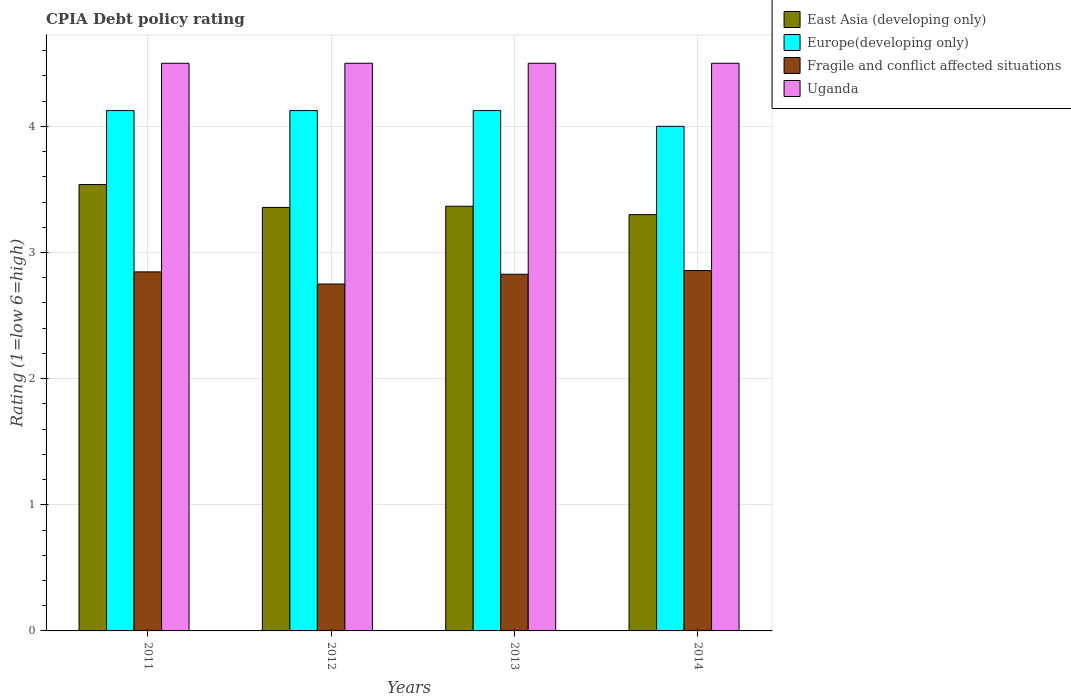How many different coloured bars are there?
Keep it short and to the point. 4. How many groups of bars are there?
Give a very brief answer. 4. Are the number of bars per tick equal to the number of legend labels?
Your response must be concise. Yes. How many bars are there on the 2nd tick from the left?
Offer a very short reply. 4. How many bars are there on the 1st tick from the right?
Keep it short and to the point. 4. What is the label of the 2nd group of bars from the left?
Offer a terse response. 2012. What is the CPIA rating in Europe(developing only) in 2014?
Ensure brevity in your answer.  4. Across all years, what is the maximum CPIA rating in Uganda?
Provide a short and direct response. 4.5. Across all years, what is the minimum CPIA rating in Europe(developing only)?
Give a very brief answer. 4. What is the total CPIA rating in East Asia (developing only) in the graph?
Provide a succinct answer. 13.56. What is the difference between the CPIA rating in East Asia (developing only) in 2011 and that in 2013?
Give a very brief answer. 0.17. What is the difference between the CPIA rating in East Asia (developing only) in 2011 and the CPIA rating in Europe(developing only) in 2013?
Offer a terse response. -0.59. What is the average CPIA rating in Europe(developing only) per year?
Provide a succinct answer. 4.09. In the year 2011, what is the difference between the CPIA rating in Fragile and conflict affected situations and CPIA rating in Europe(developing only)?
Ensure brevity in your answer.  -1.28. Is the difference between the CPIA rating in Fragile and conflict affected situations in 2012 and 2013 greater than the difference between the CPIA rating in Europe(developing only) in 2012 and 2013?
Provide a short and direct response. No. What is the difference between the highest and the second highest CPIA rating in East Asia (developing only)?
Give a very brief answer. 0.17. What is the difference between the highest and the lowest CPIA rating in Fragile and conflict affected situations?
Your answer should be compact. 0.11. Is it the case that in every year, the sum of the CPIA rating in Europe(developing only) and CPIA rating in East Asia (developing only) is greater than the sum of CPIA rating in Fragile and conflict affected situations and CPIA rating in Uganda?
Provide a succinct answer. No. What does the 1st bar from the left in 2012 represents?
Provide a succinct answer. East Asia (developing only). What does the 4th bar from the right in 2014 represents?
Your answer should be very brief. East Asia (developing only). Is it the case that in every year, the sum of the CPIA rating in East Asia (developing only) and CPIA rating in Uganda is greater than the CPIA rating in Europe(developing only)?
Keep it short and to the point. Yes. How many years are there in the graph?
Your answer should be very brief. 4. What is the difference between two consecutive major ticks on the Y-axis?
Ensure brevity in your answer.  1. Does the graph contain any zero values?
Give a very brief answer. No. Where does the legend appear in the graph?
Your answer should be very brief. Top right. What is the title of the graph?
Provide a short and direct response. CPIA Debt policy rating. Does "Ecuador" appear as one of the legend labels in the graph?
Provide a succinct answer. No. What is the label or title of the Y-axis?
Make the answer very short. Rating (1=low 6=high). What is the Rating (1=low 6=high) of East Asia (developing only) in 2011?
Offer a terse response. 3.54. What is the Rating (1=low 6=high) in Europe(developing only) in 2011?
Make the answer very short. 4.12. What is the Rating (1=low 6=high) in Fragile and conflict affected situations in 2011?
Make the answer very short. 2.85. What is the Rating (1=low 6=high) in East Asia (developing only) in 2012?
Your answer should be very brief. 3.36. What is the Rating (1=low 6=high) in Europe(developing only) in 2012?
Your response must be concise. 4.12. What is the Rating (1=low 6=high) of Fragile and conflict affected situations in 2012?
Make the answer very short. 2.75. What is the Rating (1=low 6=high) in Uganda in 2012?
Offer a terse response. 4.5. What is the Rating (1=low 6=high) in East Asia (developing only) in 2013?
Your response must be concise. 3.37. What is the Rating (1=low 6=high) of Europe(developing only) in 2013?
Make the answer very short. 4.12. What is the Rating (1=low 6=high) of Fragile and conflict affected situations in 2013?
Your answer should be compact. 2.83. What is the Rating (1=low 6=high) in Uganda in 2013?
Ensure brevity in your answer.  4.5. What is the Rating (1=low 6=high) of East Asia (developing only) in 2014?
Make the answer very short. 3.3. What is the Rating (1=low 6=high) of Europe(developing only) in 2014?
Offer a terse response. 4. What is the Rating (1=low 6=high) in Fragile and conflict affected situations in 2014?
Keep it short and to the point. 2.86. What is the Rating (1=low 6=high) in Uganda in 2014?
Your answer should be very brief. 4.5. Across all years, what is the maximum Rating (1=low 6=high) of East Asia (developing only)?
Your answer should be very brief. 3.54. Across all years, what is the maximum Rating (1=low 6=high) in Europe(developing only)?
Your response must be concise. 4.12. Across all years, what is the maximum Rating (1=low 6=high) of Fragile and conflict affected situations?
Offer a terse response. 2.86. Across all years, what is the maximum Rating (1=low 6=high) of Uganda?
Offer a very short reply. 4.5. Across all years, what is the minimum Rating (1=low 6=high) of East Asia (developing only)?
Offer a very short reply. 3.3. Across all years, what is the minimum Rating (1=low 6=high) of Europe(developing only)?
Keep it short and to the point. 4. Across all years, what is the minimum Rating (1=low 6=high) in Fragile and conflict affected situations?
Make the answer very short. 2.75. Across all years, what is the minimum Rating (1=low 6=high) of Uganda?
Provide a short and direct response. 4.5. What is the total Rating (1=low 6=high) of East Asia (developing only) in the graph?
Make the answer very short. 13.56. What is the total Rating (1=low 6=high) in Europe(developing only) in the graph?
Provide a short and direct response. 16.38. What is the total Rating (1=low 6=high) in Fragile and conflict affected situations in the graph?
Your answer should be very brief. 11.28. What is the difference between the Rating (1=low 6=high) of East Asia (developing only) in 2011 and that in 2012?
Provide a succinct answer. 0.18. What is the difference between the Rating (1=low 6=high) in Fragile and conflict affected situations in 2011 and that in 2012?
Offer a very short reply. 0.1. What is the difference between the Rating (1=low 6=high) of East Asia (developing only) in 2011 and that in 2013?
Make the answer very short. 0.17. What is the difference between the Rating (1=low 6=high) of Europe(developing only) in 2011 and that in 2013?
Ensure brevity in your answer.  0. What is the difference between the Rating (1=low 6=high) of Fragile and conflict affected situations in 2011 and that in 2013?
Provide a succinct answer. 0.02. What is the difference between the Rating (1=low 6=high) in Uganda in 2011 and that in 2013?
Ensure brevity in your answer.  0. What is the difference between the Rating (1=low 6=high) of East Asia (developing only) in 2011 and that in 2014?
Give a very brief answer. 0.24. What is the difference between the Rating (1=low 6=high) in Fragile and conflict affected situations in 2011 and that in 2014?
Offer a terse response. -0.01. What is the difference between the Rating (1=low 6=high) of Uganda in 2011 and that in 2014?
Your response must be concise. 0. What is the difference between the Rating (1=low 6=high) in East Asia (developing only) in 2012 and that in 2013?
Give a very brief answer. -0.01. What is the difference between the Rating (1=low 6=high) in Fragile and conflict affected situations in 2012 and that in 2013?
Offer a very short reply. -0.08. What is the difference between the Rating (1=low 6=high) in Uganda in 2012 and that in 2013?
Your answer should be compact. 0. What is the difference between the Rating (1=low 6=high) of East Asia (developing only) in 2012 and that in 2014?
Your response must be concise. 0.06. What is the difference between the Rating (1=low 6=high) of Fragile and conflict affected situations in 2012 and that in 2014?
Offer a very short reply. -0.11. What is the difference between the Rating (1=low 6=high) in Uganda in 2012 and that in 2014?
Provide a succinct answer. 0. What is the difference between the Rating (1=low 6=high) in East Asia (developing only) in 2013 and that in 2014?
Your response must be concise. 0.07. What is the difference between the Rating (1=low 6=high) in Fragile and conflict affected situations in 2013 and that in 2014?
Your answer should be compact. -0.03. What is the difference between the Rating (1=low 6=high) of East Asia (developing only) in 2011 and the Rating (1=low 6=high) of Europe(developing only) in 2012?
Make the answer very short. -0.59. What is the difference between the Rating (1=low 6=high) of East Asia (developing only) in 2011 and the Rating (1=low 6=high) of Fragile and conflict affected situations in 2012?
Make the answer very short. 0.79. What is the difference between the Rating (1=low 6=high) in East Asia (developing only) in 2011 and the Rating (1=low 6=high) in Uganda in 2012?
Keep it short and to the point. -0.96. What is the difference between the Rating (1=low 6=high) of Europe(developing only) in 2011 and the Rating (1=low 6=high) of Fragile and conflict affected situations in 2012?
Give a very brief answer. 1.38. What is the difference between the Rating (1=low 6=high) of Europe(developing only) in 2011 and the Rating (1=low 6=high) of Uganda in 2012?
Offer a very short reply. -0.38. What is the difference between the Rating (1=low 6=high) of Fragile and conflict affected situations in 2011 and the Rating (1=low 6=high) of Uganda in 2012?
Keep it short and to the point. -1.65. What is the difference between the Rating (1=low 6=high) of East Asia (developing only) in 2011 and the Rating (1=low 6=high) of Europe(developing only) in 2013?
Ensure brevity in your answer.  -0.59. What is the difference between the Rating (1=low 6=high) in East Asia (developing only) in 2011 and the Rating (1=low 6=high) in Fragile and conflict affected situations in 2013?
Ensure brevity in your answer.  0.71. What is the difference between the Rating (1=low 6=high) of East Asia (developing only) in 2011 and the Rating (1=low 6=high) of Uganda in 2013?
Ensure brevity in your answer.  -0.96. What is the difference between the Rating (1=low 6=high) in Europe(developing only) in 2011 and the Rating (1=low 6=high) in Fragile and conflict affected situations in 2013?
Make the answer very short. 1.3. What is the difference between the Rating (1=low 6=high) of Europe(developing only) in 2011 and the Rating (1=low 6=high) of Uganda in 2013?
Provide a succinct answer. -0.38. What is the difference between the Rating (1=low 6=high) of Fragile and conflict affected situations in 2011 and the Rating (1=low 6=high) of Uganda in 2013?
Your answer should be very brief. -1.65. What is the difference between the Rating (1=low 6=high) of East Asia (developing only) in 2011 and the Rating (1=low 6=high) of Europe(developing only) in 2014?
Ensure brevity in your answer.  -0.46. What is the difference between the Rating (1=low 6=high) in East Asia (developing only) in 2011 and the Rating (1=low 6=high) in Fragile and conflict affected situations in 2014?
Provide a short and direct response. 0.68. What is the difference between the Rating (1=low 6=high) of East Asia (developing only) in 2011 and the Rating (1=low 6=high) of Uganda in 2014?
Provide a succinct answer. -0.96. What is the difference between the Rating (1=low 6=high) in Europe(developing only) in 2011 and the Rating (1=low 6=high) in Fragile and conflict affected situations in 2014?
Keep it short and to the point. 1.27. What is the difference between the Rating (1=low 6=high) of Europe(developing only) in 2011 and the Rating (1=low 6=high) of Uganda in 2014?
Keep it short and to the point. -0.38. What is the difference between the Rating (1=low 6=high) in Fragile and conflict affected situations in 2011 and the Rating (1=low 6=high) in Uganda in 2014?
Make the answer very short. -1.65. What is the difference between the Rating (1=low 6=high) of East Asia (developing only) in 2012 and the Rating (1=low 6=high) of Europe(developing only) in 2013?
Your answer should be very brief. -0.77. What is the difference between the Rating (1=low 6=high) in East Asia (developing only) in 2012 and the Rating (1=low 6=high) in Fragile and conflict affected situations in 2013?
Your response must be concise. 0.53. What is the difference between the Rating (1=low 6=high) of East Asia (developing only) in 2012 and the Rating (1=low 6=high) of Uganda in 2013?
Offer a terse response. -1.14. What is the difference between the Rating (1=low 6=high) in Europe(developing only) in 2012 and the Rating (1=low 6=high) in Fragile and conflict affected situations in 2013?
Offer a very short reply. 1.3. What is the difference between the Rating (1=low 6=high) of Europe(developing only) in 2012 and the Rating (1=low 6=high) of Uganda in 2013?
Ensure brevity in your answer.  -0.38. What is the difference between the Rating (1=low 6=high) of Fragile and conflict affected situations in 2012 and the Rating (1=low 6=high) of Uganda in 2013?
Offer a terse response. -1.75. What is the difference between the Rating (1=low 6=high) in East Asia (developing only) in 2012 and the Rating (1=low 6=high) in Europe(developing only) in 2014?
Ensure brevity in your answer.  -0.64. What is the difference between the Rating (1=low 6=high) of East Asia (developing only) in 2012 and the Rating (1=low 6=high) of Fragile and conflict affected situations in 2014?
Ensure brevity in your answer.  0.5. What is the difference between the Rating (1=low 6=high) of East Asia (developing only) in 2012 and the Rating (1=low 6=high) of Uganda in 2014?
Keep it short and to the point. -1.14. What is the difference between the Rating (1=low 6=high) of Europe(developing only) in 2012 and the Rating (1=low 6=high) of Fragile and conflict affected situations in 2014?
Your answer should be very brief. 1.27. What is the difference between the Rating (1=low 6=high) of Europe(developing only) in 2012 and the Rating (1=low 6=high) of Uganda in 2014?
Provide a succinct answer. -0.38. What is the difference between the Rating (1=low 6=high) of Fragile and conflict affected situations in 2012 and the Rating (1=low 6=high) of Uganda in 2014?
Your answer should be very brief. -1.75. What is the difference between the Rating (1=low 6=high) in East Asia (developing only) in 2013 and the Rating (1=low 6=high) in Europe(developing only) in 2014?
Offer a terse response. -0.63. What is the difference between the Rating (1=low 6=high) in East Asia (developing only) in 2013 and the Rating (1=low 6=high) in Fragile and conflict affected situations in 2014?
Offer a terse response. 0.51. What is the difference between the Rating (1=low 6=high) in East Asia (developing only) in 2013 and the Rating (1=low 6=high) in Uganda in 2014?
Ensure brevity in your answer.  -1.13. What is the difference between the Rating (1=low 6=high) of Europe(developing only) in 2013 and the Rating (1=low 6=high) of Fragile and conflict affected situations in 2014?
Your answer should be very brief. 1.27. What is the difference between the Rating (1=low 6=high) of Europe(developing only) in 2013 and the Rating (1=low 6=high) of Uganda in 2014?
Offer a very short reply. -0.38. What is the difference between the Rating (1=low 6=high) of Fragile and conflict affected situations in 2013 and the Rating (1=low 6=high) of Uganda in 2014?
Your answer should be very brief. -1.67. What is the average Rating (1=low 6=high) in East Asia (developing only) per year?
Provide a succinct answer. 3.39. What is the average Rating (1=low 6=high) in Europe(developing only) per year?
Provide a short and direct response. 4.09. What is the average Rating (1=low 6=high) in Fragile and conflict affected situations per year?
Offer a terse response. 2.82. What is the average Rating (1=low 6=high) of Uganda per year?
Keep it short and to the point. 4.5. In the year 2011, what is the difference between the Rating (1=low 6=high) of East Asia (developing only) and Rating (1=low 6=high) of Europe(developing only)?
Your answer should be very brief. -0.59. In the year 2011, what is the difference between the Rating (1=low 6=high) of East Asia (developing only) and Rating (1=low 6=high) of Fragile and conflict affected situations?
Your response must be concise. 0.69. In the year 2011, what is the difference between the Rating (1=low 6=high) in East Asia (developing only) and Rating (1=low 6=high) in Uganda?
Make the answer very short. -0.96. In the year 2011, what is the difference between the Rating (1=low 6=high) in Europe(developing only) and Rating (1=low 6=high) in Fragile and conflict affected situations?
Provide a succinct answer. 1.28. In the year 2011, what is the difference between the Rating (1=low 6=high) of Europe(developing only) and Rating (1=low 6=high) of Uganda?
Make the answer very short. -0.38. In the year 2011, what is the difference between the Rating (1=low 6=high) of Fragile and conflict affected situations and Rating (1=low 6=high) of Uganda?
Provide a short and direct response. -1.65. In the year 2012, what is the difference between the Rating (1=low 6=high) in East Asia (developing only) and Rating (1=low 6=high) in Europe(developing only)?
Make the answer very short. -0.77. In the year 2012, what is the difference between the Rating (1=low 6=high) in East Asia (developing only) and Rating (1=low 6=high) in Fragile and conflict affected situations?
Provide a succinct answer. 0.61. In the year 2012, what is the difference between the Rating (1=low 6=high) of East Asia (developing only) and Rating (1=low 6=high) of Uganda?
Make the answer very short. -1.14. In the year 2012, what is the difference between the Rating (1=low 6=high) of Europe(developing only) and Rating (1=low 6=high) of Fragile and conflict affected situations?
Provide a succinct answer. 1.38. In the year 2012, what is the difference between the Rating (1=low 6=high) in Europe(developing only) and Rating (1=low 6=high) in Uganda?
Offer a very short reply. -0.38. In the year 2012, what is the difference between the Rating (1=low 6=high) in Fragile and conflict affected situations and Rating (1=low 6=high) in Uganda?
Give a very brief answer. -1.75. In the year 2013, what is the difference between the Rating (1=low 6=high) in East Asia (developing only) and Rating (1=low 6=high) in Europe(developing only)?
Give a very brief answer. -0.76. In the year 2013, what is the difference between the Rating (1=low 6=high) of East Asia (developing only) and Rating (1=low 6=high) of Fragile and conflict affected situations?
Your answer should be very brief. 0.54. In the year 2013, what is the difference between the Rating (1=low 6=high) of East Asia (developing only) and Rating (1=low 6=high) of Uganda?
Your answer should be compact. -1.13. In the year 2013, what is the difference between the Rating (1=low 6=high) in Europe(developing only) and Rating (1=low 6=high) in Fragile and conflict affected situations?
Make the answer very short. 1.3. In the year 2013, what is the difference between the Rating (1=low 6=high) of Europe(developing only) and Rating (1=low 6=high) of Uganda?
Make the answer very short. -0.38. In the year 2013, what is the difference between the Rating (1=low 6=high) of Fragile and conflict affected situations and Rating (1=low 6=high) of Uganda?
Your answer should be compact. -1.67. In the year 2014, what is the difference between the Rating (1=low 6=high) of East Asia (developing only) and Rating (1=low 6=high) of Fragile and conflict affected situations?
Provide a succinct answer. 0.44. In the year 2014, what is the difference between the Rating (1=low 6=high) of Europe(developing only) and Rating (1=low 6=high) of Uganda?
Offer a terse response. -0.5. In the year 2014, what is the difference between the Rating (1=low 6=high) in Fragile and conflict affected situations and Rating (1=low 6=high) in Uganda?
Provide a succinct answer. -1.64. What is the ratio of the Rating (1=low 6=high) of East Asia (developing only) in 2011 to that in 2012?
Provide a short and direct response. 1.05. What is the ratio of the Rating (1=low 6=high) in Fragile and conflict affected situations in 2011 to that in 2012?
Offer a very short reply. 1.03. What is the ratio of the Rating (1=low 6=high) in East Asia (developing only) in 2011 to that in 2013?
Give a very brief answer. 1.05. What is the ratio of the Rating (1=low 6=high) in Fragile and conflict affected situations in 2011 to that in 2013?
Your response must be concise. 1.01. What is the ratio of the Rating (1=low 6=high) in East Asia (developing only) in 2011 to that in 2014?
Give a very brief answer. 1.07. What is the ratio of the Rating (1=low 6=high) of Europe(developing only) in 2011 to that in 2014?
Ensure brevity in your answer.  1.03. What is the ratio of the Rating (1=low 6=high) in Europe(developing only) in 2012 to that in 2013?
Give a very brief answer. 1. What is the ratio of the Rating (1=low 6=high) of Fragile and conflict affected situations in 2012 to that in 2013?
Give a very brief answer. 0.97. What is the ratio of the Rating (1=low 6=high) of Uganda in 2012 to that in 2013?
Offer a very short reply. 1. What is the ratio of the Rating (1=low 6=high) of East Asia (developing only) in 2012 to that in 2014?
Your response must be concise. 1.02. What is the ratio of the Rating (1=low 6=high) in Europe(developing only) in 2012 to that in 2014?
Provide a succinct answer. 1.03. What is the ratio of the Rating (1=low 6=high) of Fragile and conflict affected situations in 2012 to that in 2014?
Keep it short and to the point. 0.96. What is the ratio of the Rating (1=low 6=high) in East Asia (developing only) in 2013 to that in 2014?
Your response must be concise. 1.02. What is the ratio of the Rating (1=low 6=high) in Europe(developing only) in 2013 to that in 2014?
Your answer should be compact. 1.03. What is the difference between the highest and the second highest Rating (1=low 6=high) of East Asia (developing only)?
Offer a terse response. 0.17. What is the difference between the highest and the second highest Rating (1=low 6=high) in Fragile and conflict affected situations?
Your answer should be compact. 0.01. What is the difference between the highest and the lowest Rating (1=low 6=high) in East Asia (developing only)?
Keep it short and to the point. 0.24. What is the difference between the highest and the lowest Rating (1=low 6=high) of Europe(developing only)?
Provide a short and direct response. 0.12. What is the difference between the highest and the lowest Rating (1=low 6=high) of Fragile and conflict affected situations?
Your answer should be compact. 0.11. What is the difference between the highest and the lowest Rating (1=low 6=high) of Uganda?
Your answer should be very brief. 0. 